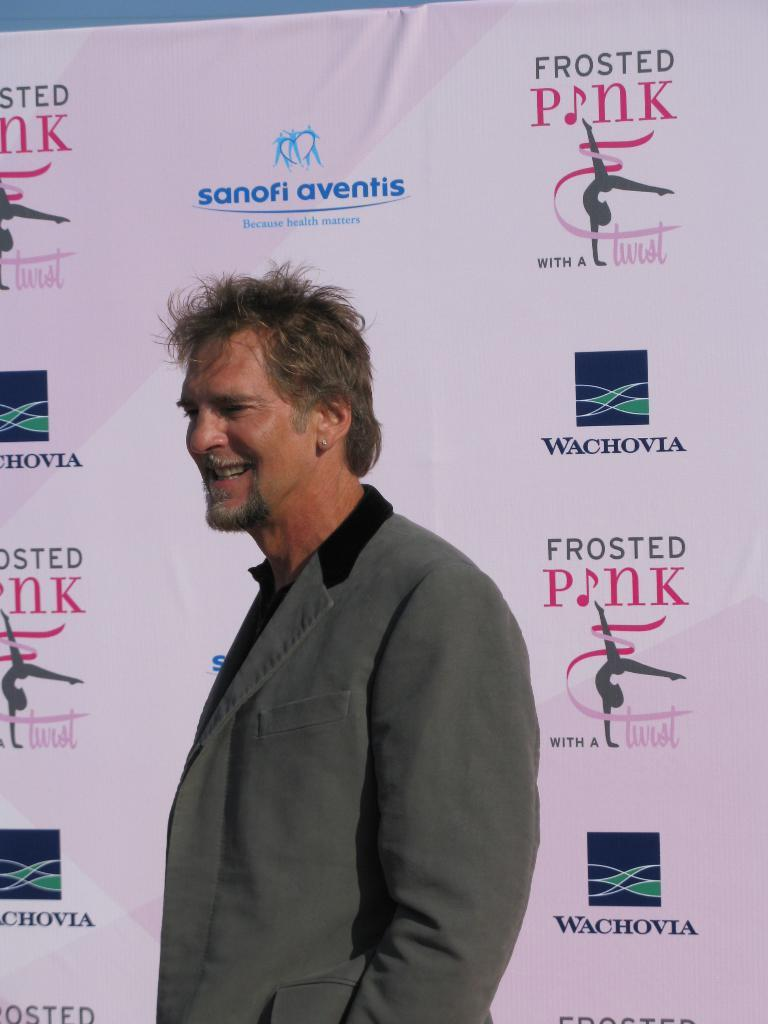What is the main subject of the image? There is a person standing in the center of the image. What is the person's expression in the image? The person is smiling. What can be seen in the background of the image? There is a banner in the background of the image. What is written or displayed on the banner? The banner contains logos and text. What type of jam is being served on the stage in the image? There is no stage or jam present in the image. Who needs to approve the person's performance in the image? The image does not show a performance or any indication of needing approval. 